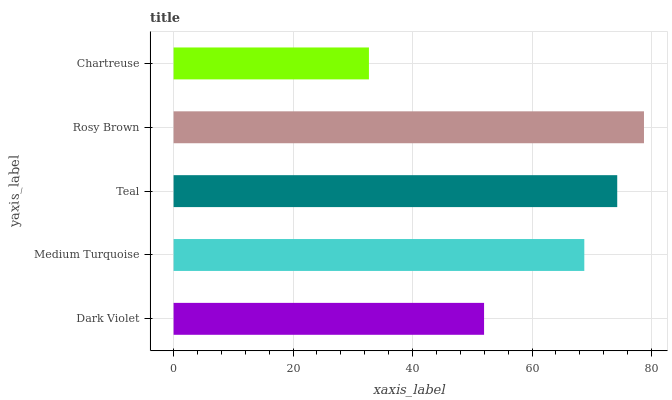Is Chartreuse the minimum?
Answer yes or no. Yes. Is Rosy Brown the maximum?
Answer yes or no. Yes. Is Medium Turquoise the minimum?
Answer yes or no. No. Is Medium Turquoise the maximum?
Answer yes or no. No. Is Medium Turquoise greater than Dark Violet?
Answer yes or no. Yes. Is Dark Violet less than Medium Turquoise?
Answer yes or no. Yes. Is Dark Violet greater than Medium Turquoise?
Answer yes or no. No. Is Medium Turquoise less than Dark Violet?
Answer yes or no. No. Is Medium Turquoise the high median?
Answer yes or no. Yes. Is Medium Turquoise the low median?
Answer yes or no. Yes. Is Chartreuse the high median?
Answer yes or no. No. Is Chartreuse the low median?
Answer yes or no. No. 